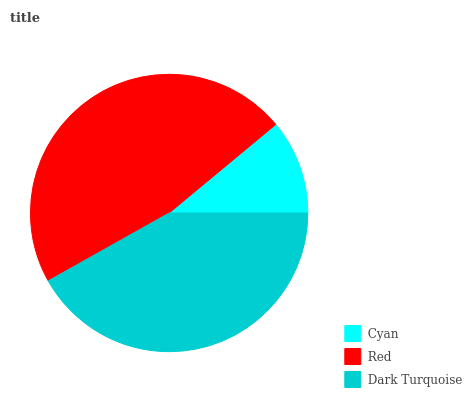Is Cyan the minimum?
Answer yes or no. Yes. Is Red the maximum?
Answer yes or no. Yes. Is Dark Turquoise the minimum?
Answer yes or no. No. Is Dark Turquoise the maximum?
Answer yes or no. No. Is Red greater than Dark Turquoise?
Answer yes or no. Yes. Is Dark Turquoise less than Red?
Answer yes or no. Yes. Is Dark Turquoise greater than Red?
Answer yes or no. No. Is Red less than Dark Turquoise?
Answer yes or no. No. Is Dark Turquoise the high median?
Answer yes or no. Yes. Is Dark Turquoise the low median?
Answer yes or no. Yes. Is Red the high median?
Answer yes or no. No. Is Red the low median?
Answer yes or no. No. 